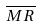Convert formula to latex. <formula><loc_0><loc_0><loc_500><loc_500>\overline { M R }</formula> 